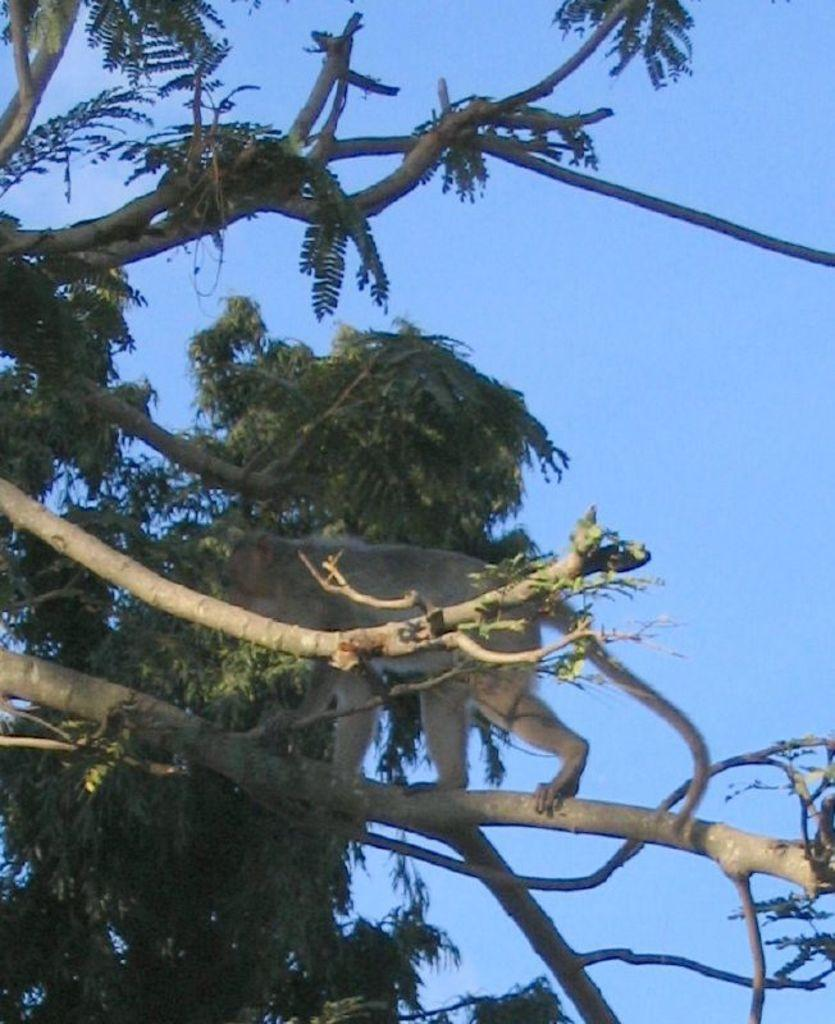What type of animal is in the image? There is a monkey in the image. What is the monkey sitting on or near in the image? The monkey is on or near branches in the image. What type of vegetation is present in the image? There are green leaves in the image. What can be seen in the background of the image? The sky is visible in the background of the image. What is the color of the sky in the image? The color of the sky is blue. How many accounts does the monkey have in the image? There are no accounts mentioned or visible in the image. Are the monkey's brothers present in the image? There is no mention or indication of the monkey having brothers in the image. 